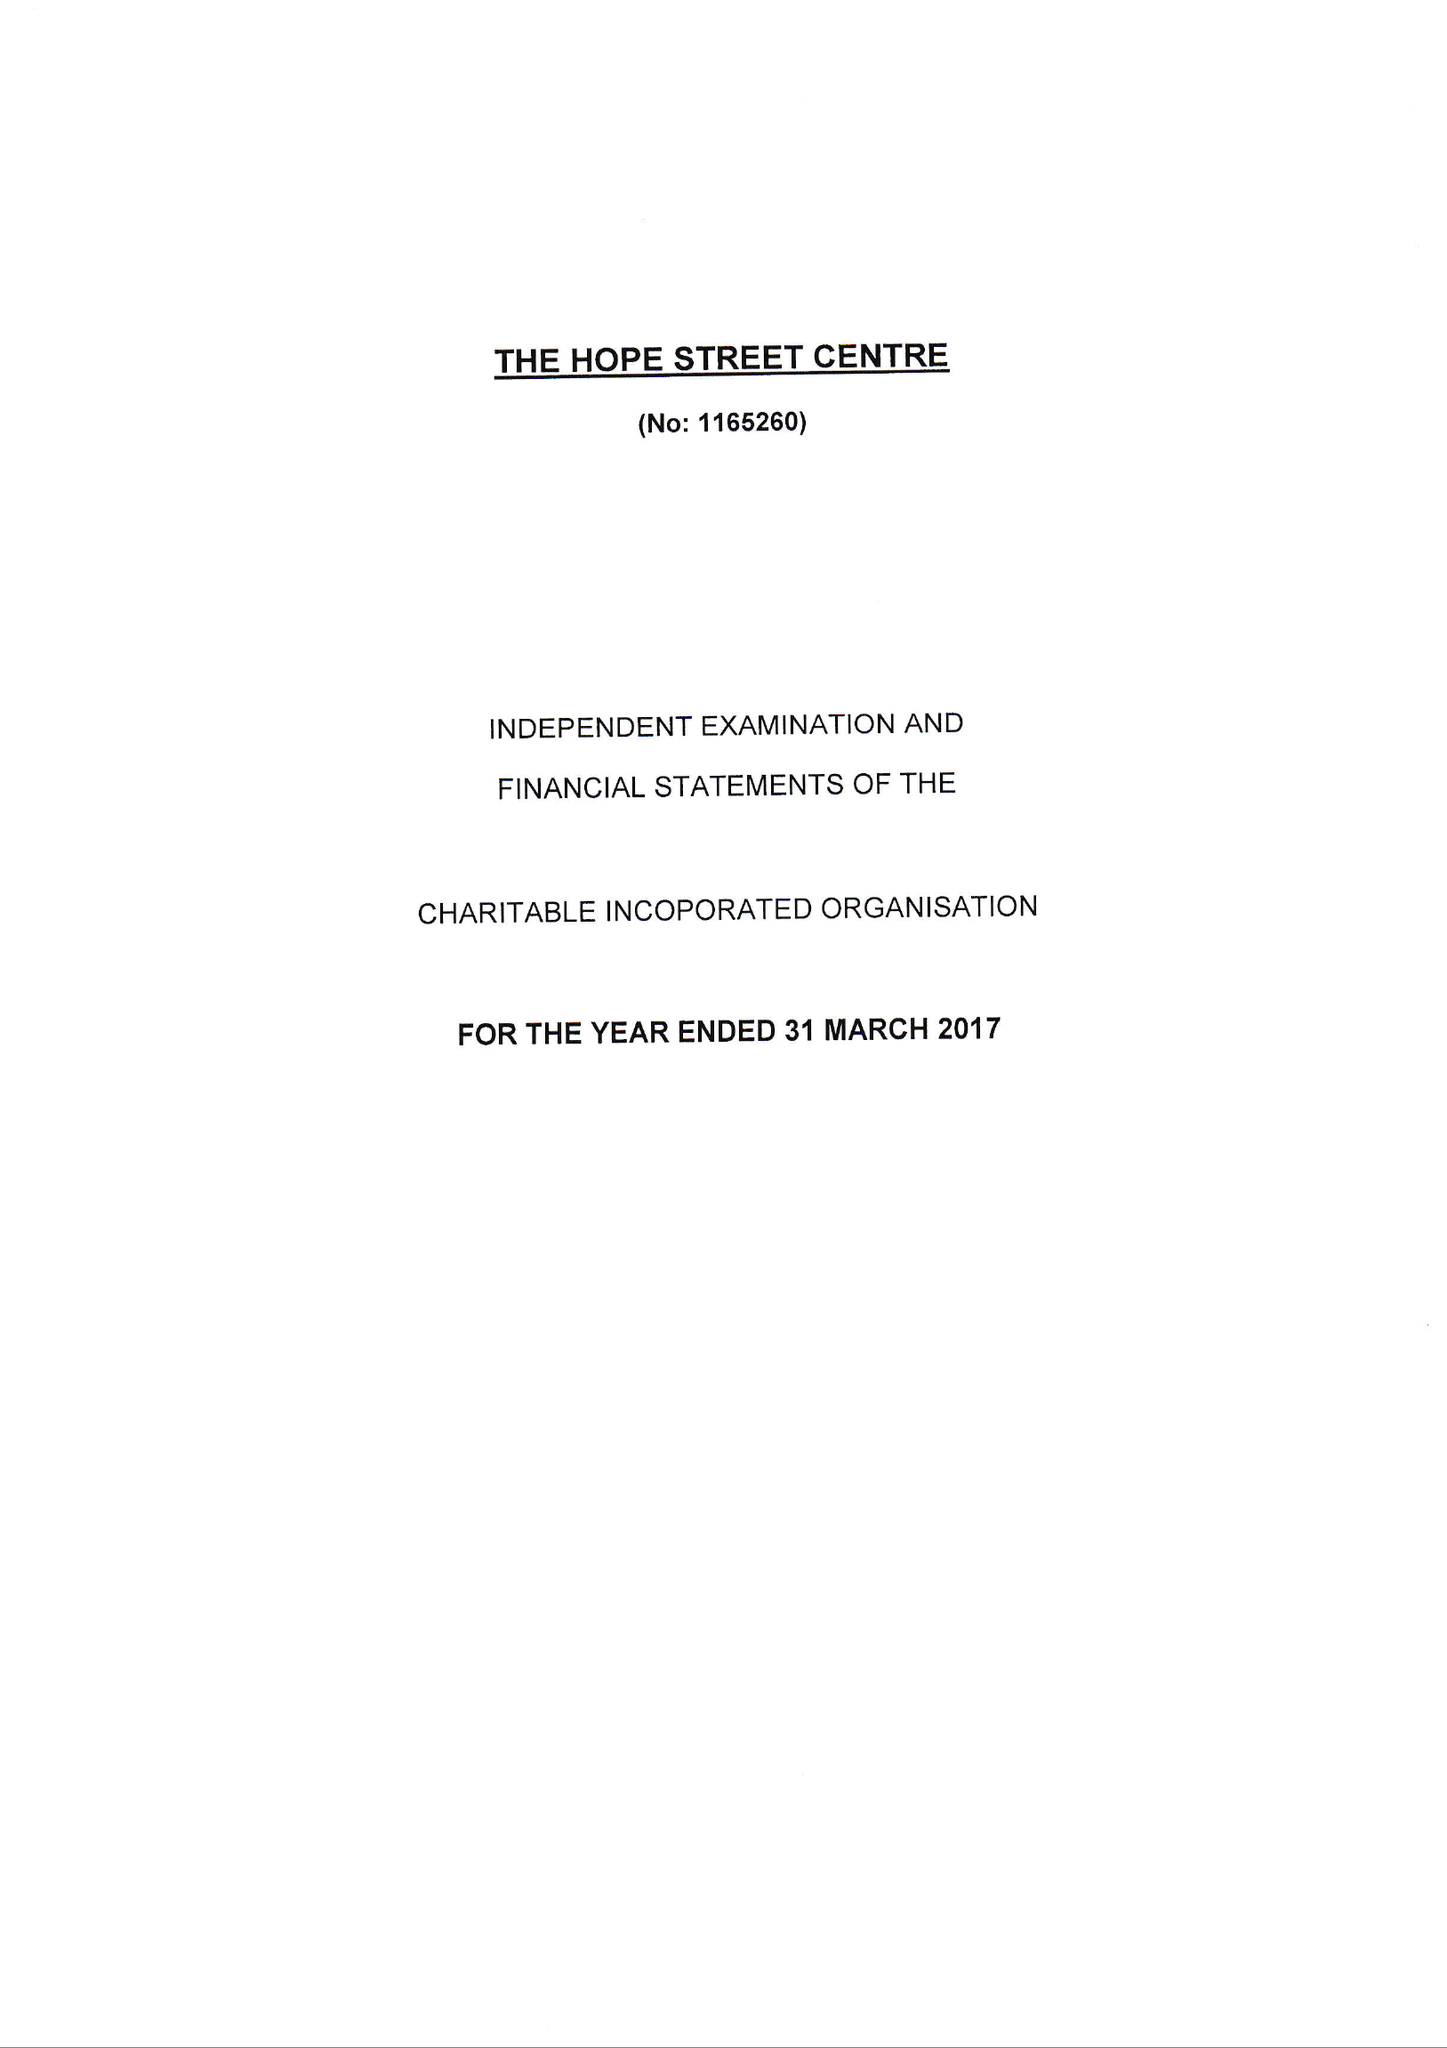What is the value for the report_date?
Answer the question using a single word or phrase. 2017-03-31 